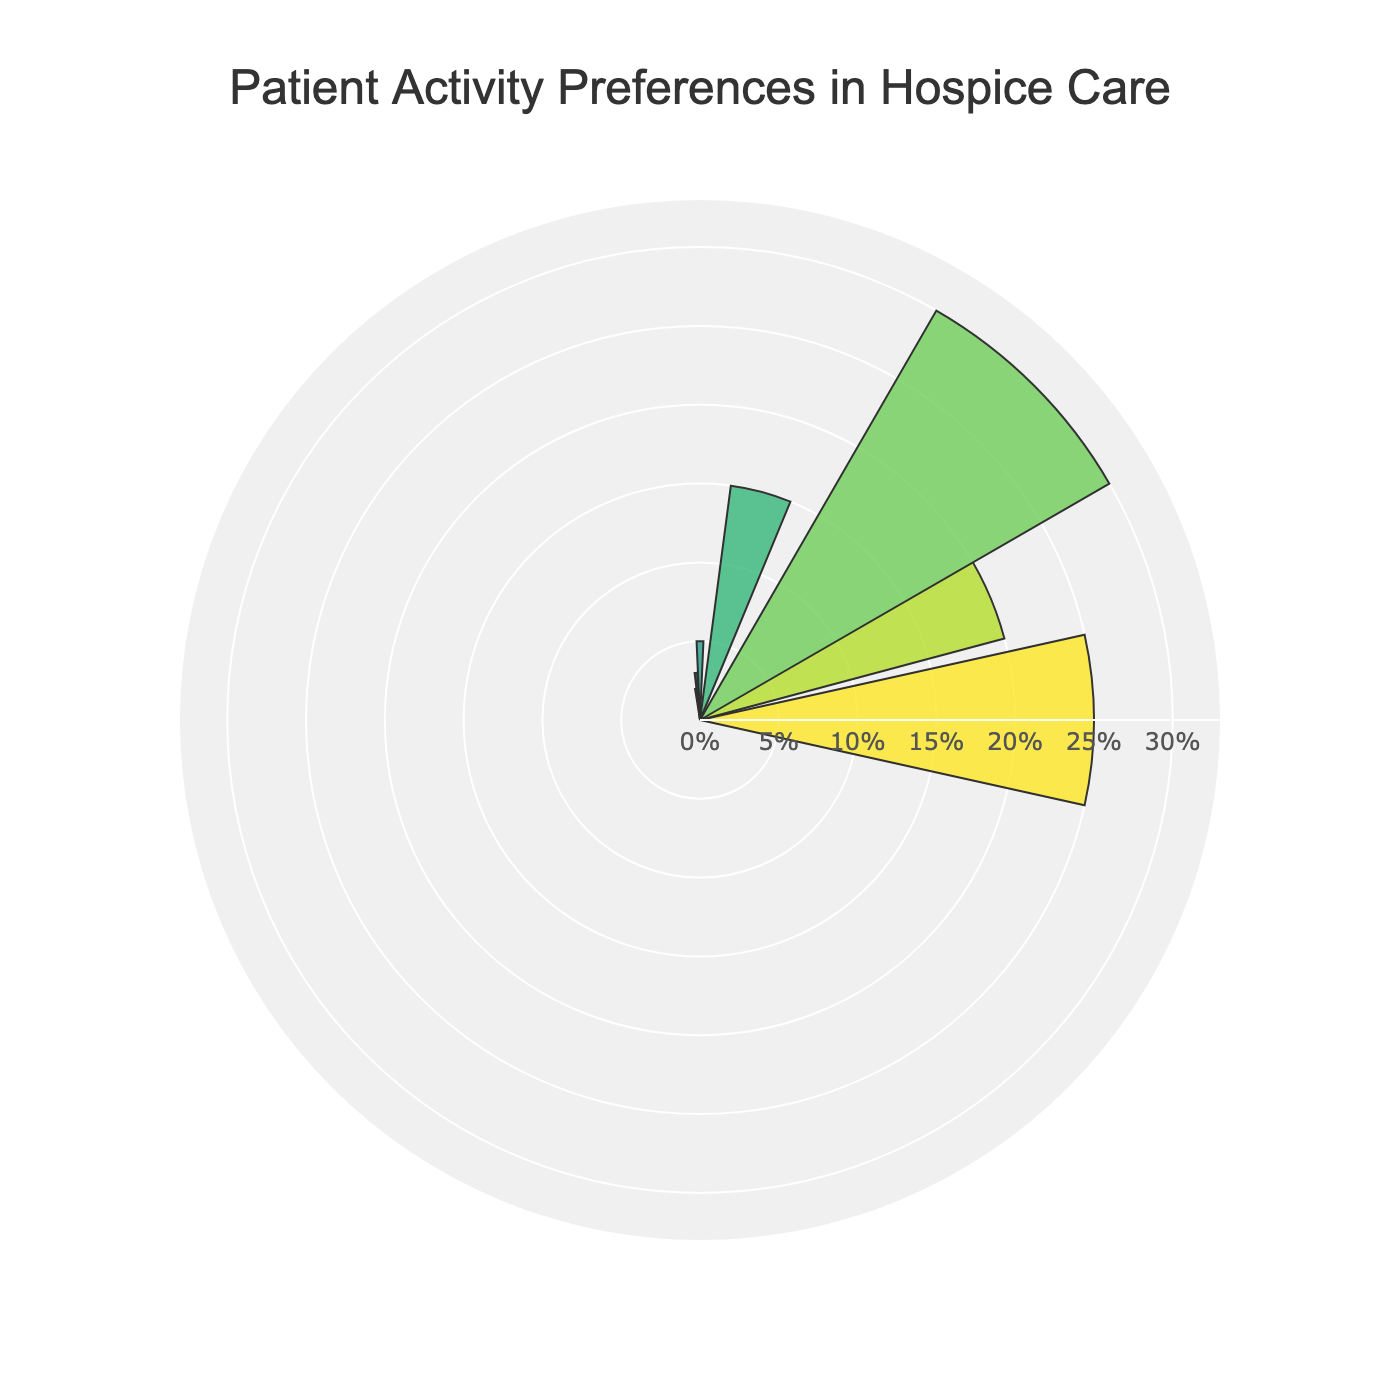What is the title of the polar area chart? The title of the chart is located at the top center of the chart. It provides a brief description of what the chart represents.
Answer: Patient Activity Preferences in Hospice Care How many activities are represented in the chart? By counting the number of distinct labels around the polar area, we can determine the number of activities being represented. Each label corresponds to one activity.
Answer: 7 Which activity occupies the largest area on the chart? The activity with the largest sector in the polar area chart is the one with the highest percentage value.
Answer: Engaging in Conversation How much more percentage do patients prefer reading compared to playing games/puzzles? To find out how much more patients prefer reading, subtract the percentage of playing games/puzzles from the percentage of reading.
Answer: 20% Combine the percentages of the two least preferred activities. What is the result? To find the combined percentage of the two least preferred activities, add their respective percentages: Pet Therapy (2%) and Art and Craft Activities (3%) which equals 2% + 3%.
Answer: 5% Which is more preferred: watching TV/movies or listening to music? By how much? Compare the percentage value for watching TV/movies and listening to music. The difference between their percentages will indicate the preference margin. Watching TV/Movies (15%) and Listening to Music (20%), so 20% - 15%.
Answer: Listening to music by 5% What is the range of the percentages shown in the chart? To find the range, subtract the smallest percentage (Pet Therapy, 2%) from the largest percentage (Engaging in Conversation, 30%).
Answer: 28% What percentage of patients prefer activities related to entertainment (reading, listening to music, watching TV/movies)? To find the total percentage for entertainment-related activities, sum the individual percentages for reading, listening to music, and watching TV/Movies: 25% + 20% + 15%.
Answer: 60% Which activities combined exceed half of the total preferences? Identify and sum the percentages of activities until they exceed 50%. Engaging in Conversation (30%) + Reading (25%)
Answer: Engaging in Conversation and Reading On the radial axis, what is the highest value shown? The highest value on the radial axis indicates the maximum percentage any one activity is given. Since Engaging in Conversation is the highest with 30%, the radial axis will accommodate slightly above this value.
Answer: 33% 